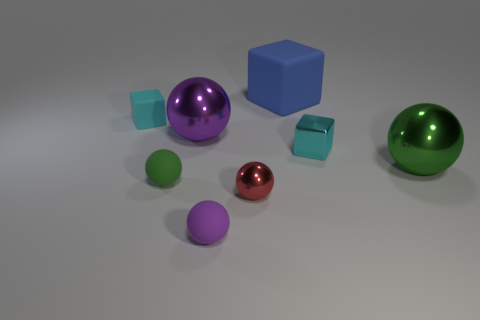Which object in this image stands out most and why? The large purple sphere stands out the most due to its size, color, and central placement, which draw the viewer's eye amidst the collection of objects.  Are there any patterns or symmetry in how the objects are arranged? While there is no strict pattern or symmetry, the objects are spaced in a way that creates a balanced composition, with a mix of large and small items distributed around the scene. 